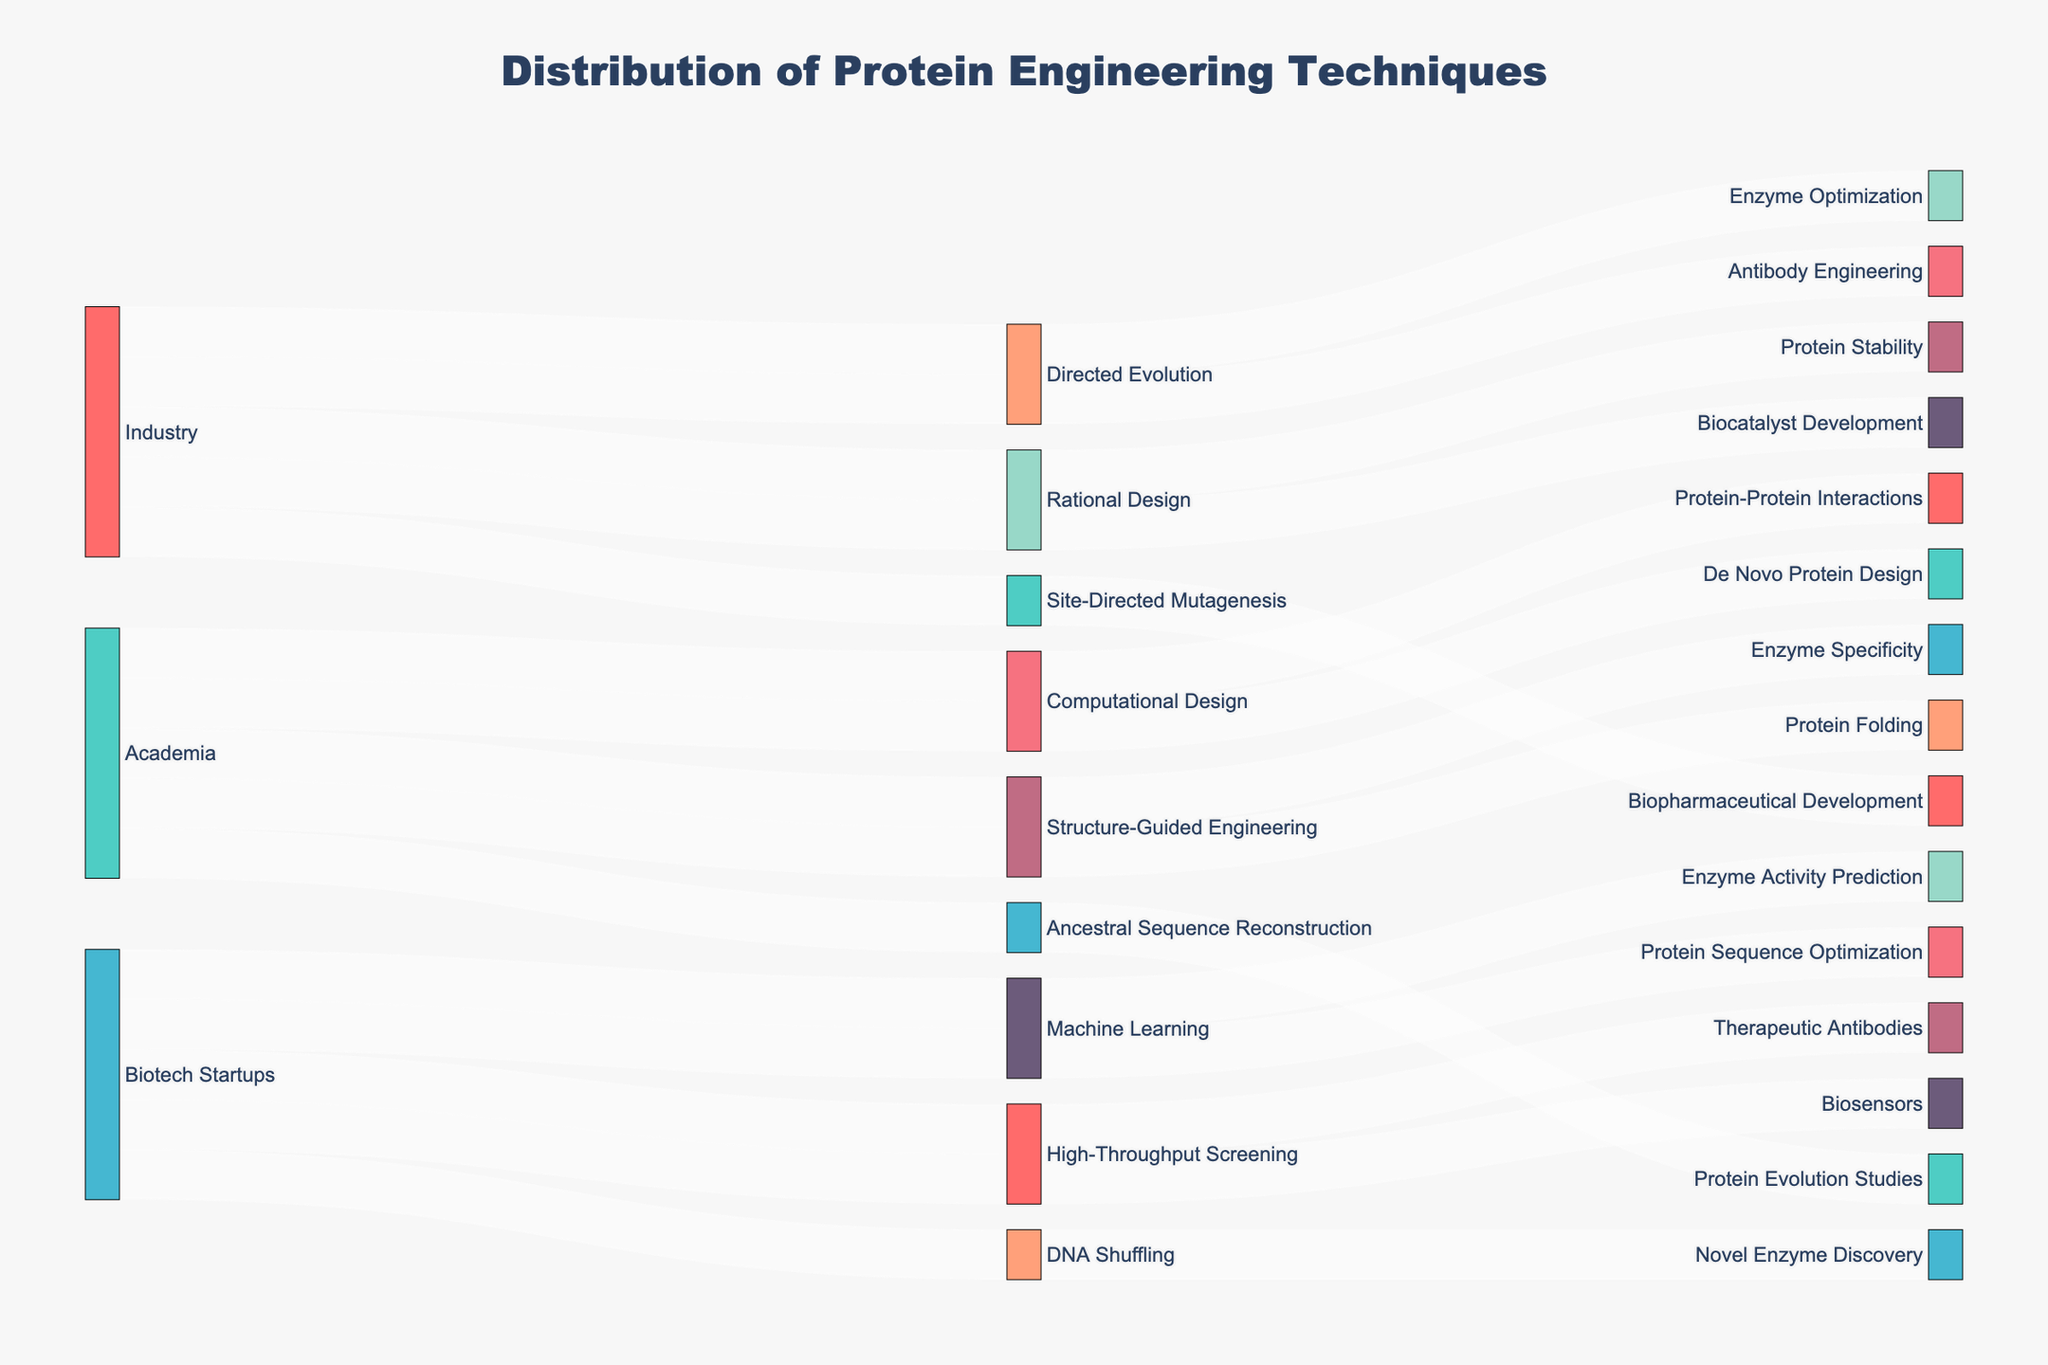What is the title of the figure? The title is usually placed at the top of the figure. Here, it mentions "Distribution of Protein Engineering Techniques."
Answer: Distribution of Protein Engineering Techniques Which sources employ the technique of Directed Evolution? The Sankey diagram illustrates the flow from sources to techniques. Observing the "Directed Evolution" node, we can see connections leading back to "Industry."
Answer: Industry How many unique applications are shown in the figure? Counting all unique labels under the "Application" category gives us the total number of unique applications. There are 12 different applications visible in the data provided.
Answer: 12 Compare the number of techniques used by academia with those used by biotech startups. By counting the connections from the "Academia" node and the "Biotech Startups" node to techniques, we see Academia has 4 techniques while Biotech Startups have 4 as well.
Answer: Academia: 4, Biotech Startups: 4 Which source has the most diverse set of techniques? To determine diversity, check the number of different techniques each source employs. "Industry" connects to 4 techniques, "Academia" connects to 4, and "Biotech Startups" also connect to 4. Since each has an equal number of techniques, no source has a more diverse set of techniques.
Answer: Tied What applications are connected to Rational Design? Following the link from the "Rational Design" technique to its applications, we see it connects to "Protein Stability" and "Biocatalyst Development."
Answer: Protein Stability, Biocatalyst Development Compare the use of Machine Learning between academia and biotech startups. The Sankey diagram shows that only Biotech Startups use "Machine Learning" through the connections from "Biotech Startups" to "Machine Learning." Academia does not connect to it.
Answer: Used only by Biotech Startups What are three applications generated from High-Throughput Screening? Inspecting the links from "High-Throughput Screening" to its applications reveals connections to "Therapeutic Antibodies" and "Biosensors."
Answer: Therapeutic Antibodies, Biosensors 